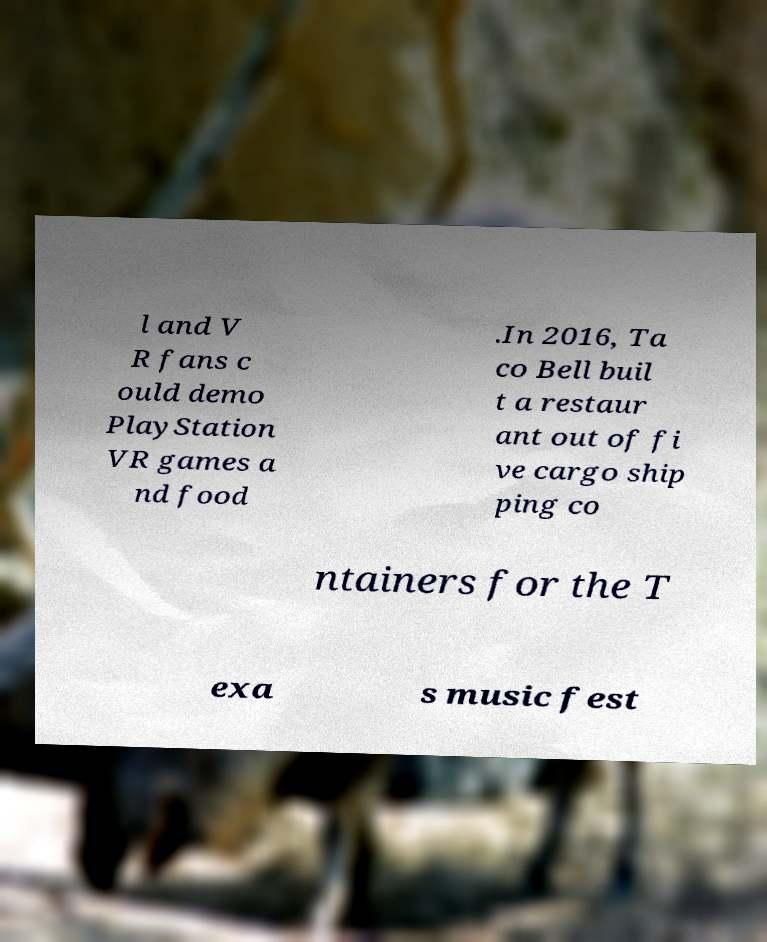Please identify and transcribe the text found in this image. l and V R fans c ould demo PlayStation VR games a nd food .In 2016, Ta co Bell buil t a restaur ant out of fi ve cargo ship ping co ntainers for the T exa s music fest 